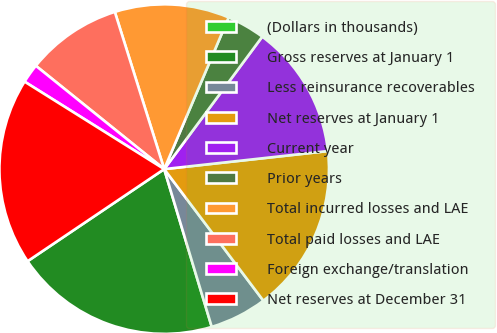Convert chart. <chart><loc_0><loc_0><loc_500><loc_500><pie_chart><fcel>(Dollars in thousands)<fcel>Gross reserves at January 1<fcel>Less reinsurance recoverables<fcel>Net reserves at January 1<fcel>Current year<fcel>Prior years<fcel>Total incurred losses and LAE<fcel>Total paid losses and LAE<fcel>Foreign exchange/translation<fcel>Net reserves at December 31<nl><fcel>0.0%<fcel>20.22%<fcel>5.62%<fcel>16.47%<fcel>13.11%<fcel>3.75%<fcel>11.24%<fcel>9.37%<fcel>1.88%<fcel>18.35%<nl></chart> 